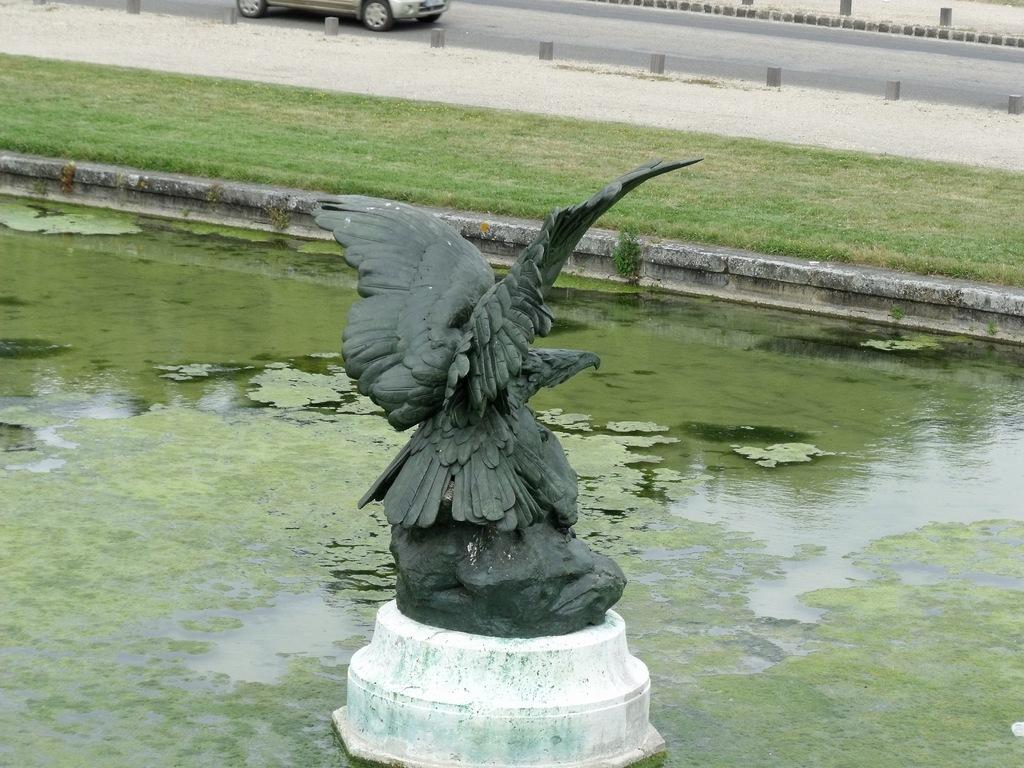What is the main subject in the image? There is an eagle statue in a small water pool in the image. What can be seen in the background of the image? There is a green lawn and a car moving on the road in the background. Can you hear the cat purring in the image? There is no cat present in the image, so it is not possible to hear a cat purring. 